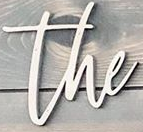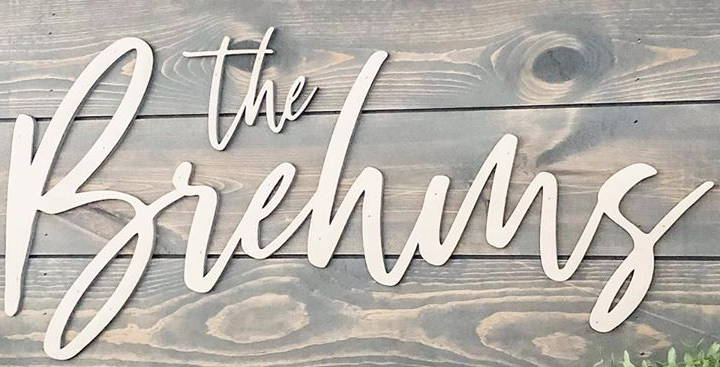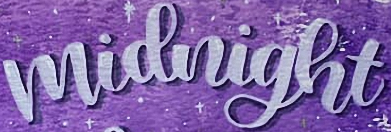What text appears in these images from left to right, separated by a semicolon? the; Brehms; midnight 